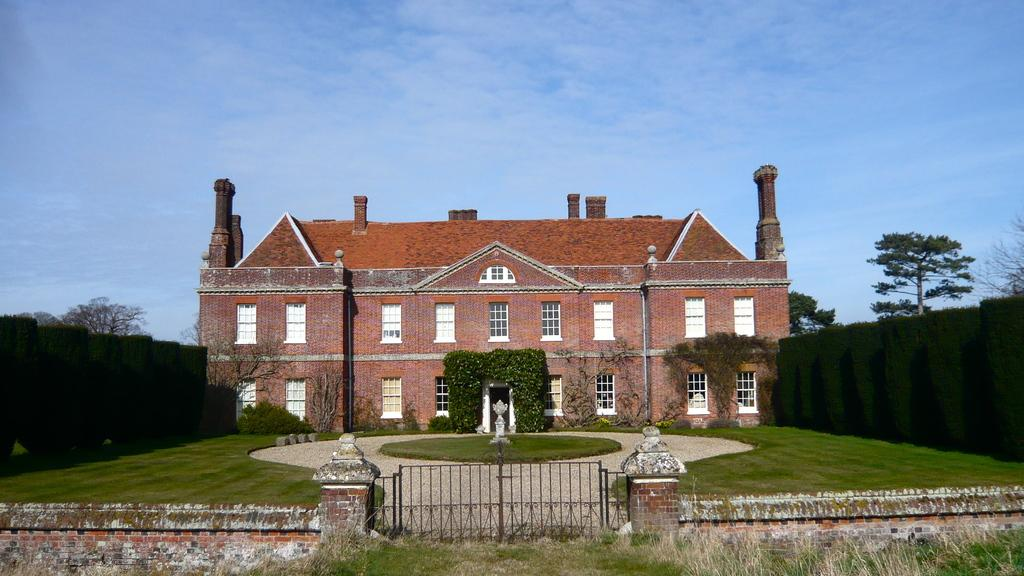What type of structure is visible in the image? There is a building in the image. What is located in front of the building? There is a gate in front of the building. What can be seen on the sides of the building? Gardening is present at the sidewalls of the building. What is visible behind the sidewalls of the building? Trees are visible behind the sidewalls of the building. What is visible at the top of the image? The sky is visible in the image. What type of writing can be seen on the vase in the image? There is no vase present in the image, so no writing can be seen on it. 